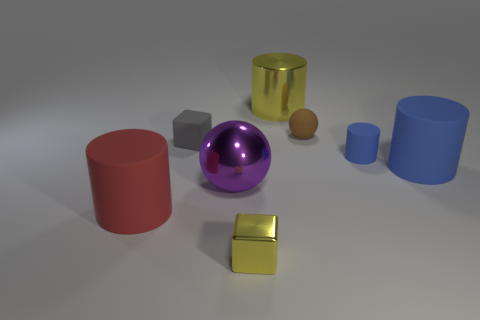Subtract all large cylinders. How many cylinders are left? 1 Subtract all yellow spheres. How many blue cylinders are left? 2 Add 1 blue metal cylinders. How many objects exist? 9 Subtract all yellow cylinders. How many cylinders are left? 3 Subtract all balls. How many objects are left? 6 Add 6 large rubber cylinders. How many large rubber cylinders exist? 8 Subtract 1 red cylinders. How many objects are left? 7 Subtract all green blocks. Subtract all red spheres. How many blocks are left? 2 Subtract all tiny yellow things. Subtract all small matte things. How many objects are left? 4 Add 6 tiny objects. How many tiny objects are left? 10 